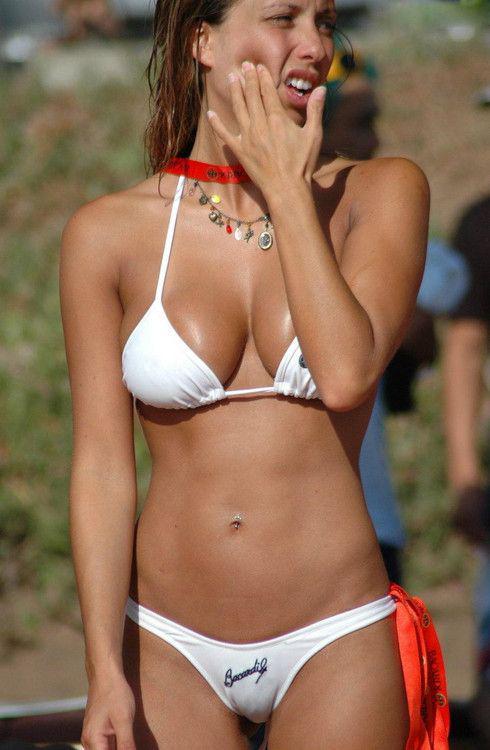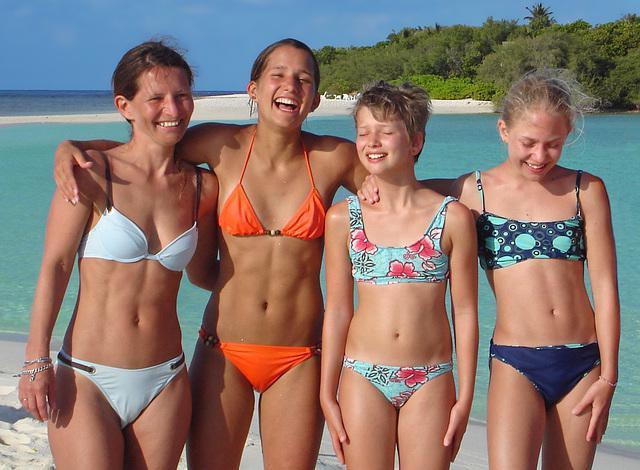The first image is the image on the left, the second image is the image on the right. Evaluate the accuracy of this statement regarding the images: "One image shows at least three females standing in a line wearing bikinis.". Is it true? Answer yes or no. Yes. The first image is the image on the left, the second image is the image on the right. For the images displayed, is the sentence "An image shows a camera-facing row of at least three girls, each standing and wearing a different swimsuit color." factually correct? Answer yes or no. Yes. 